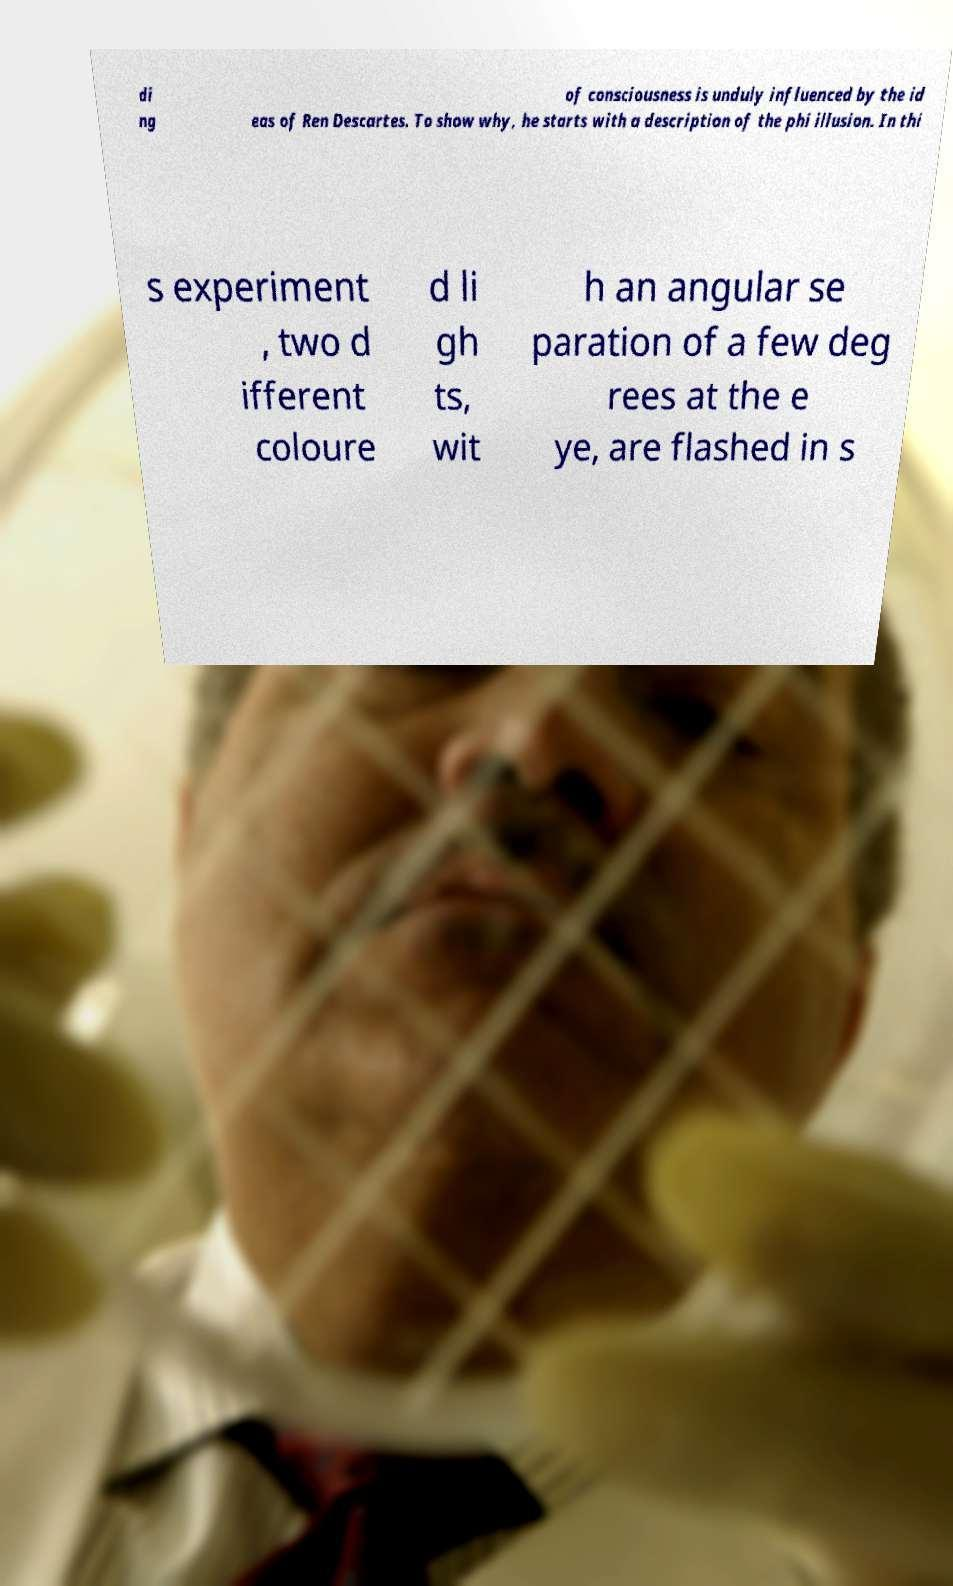I need the written content from this picture converted into text. Can you do that? di ng of consciousness is unduly influenced by the id eas of Ren Descartes. To show why, he starts with a description of the phi illusion. In thi s experiment , two d ifferent coloure d li gh ts, wit h an angular se paration of a few deg rees at the e ye, are flashed in s 